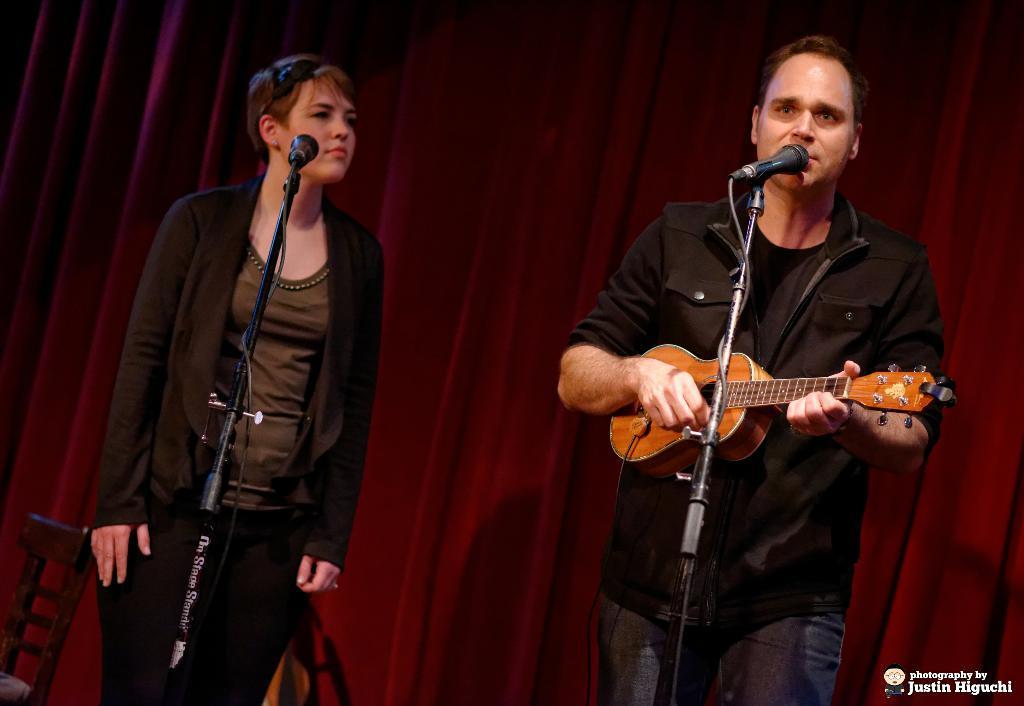In one or two sentences, can you explain what this image depicts? In this picture there are two people standing. The man to the right corner is playing guitar and singing. The woman to the left corner is looking at him. There are microphones and microphone stands in front of them. To the below left corner there is a chair and to the below right corner there is text. In the background there is curtain. 